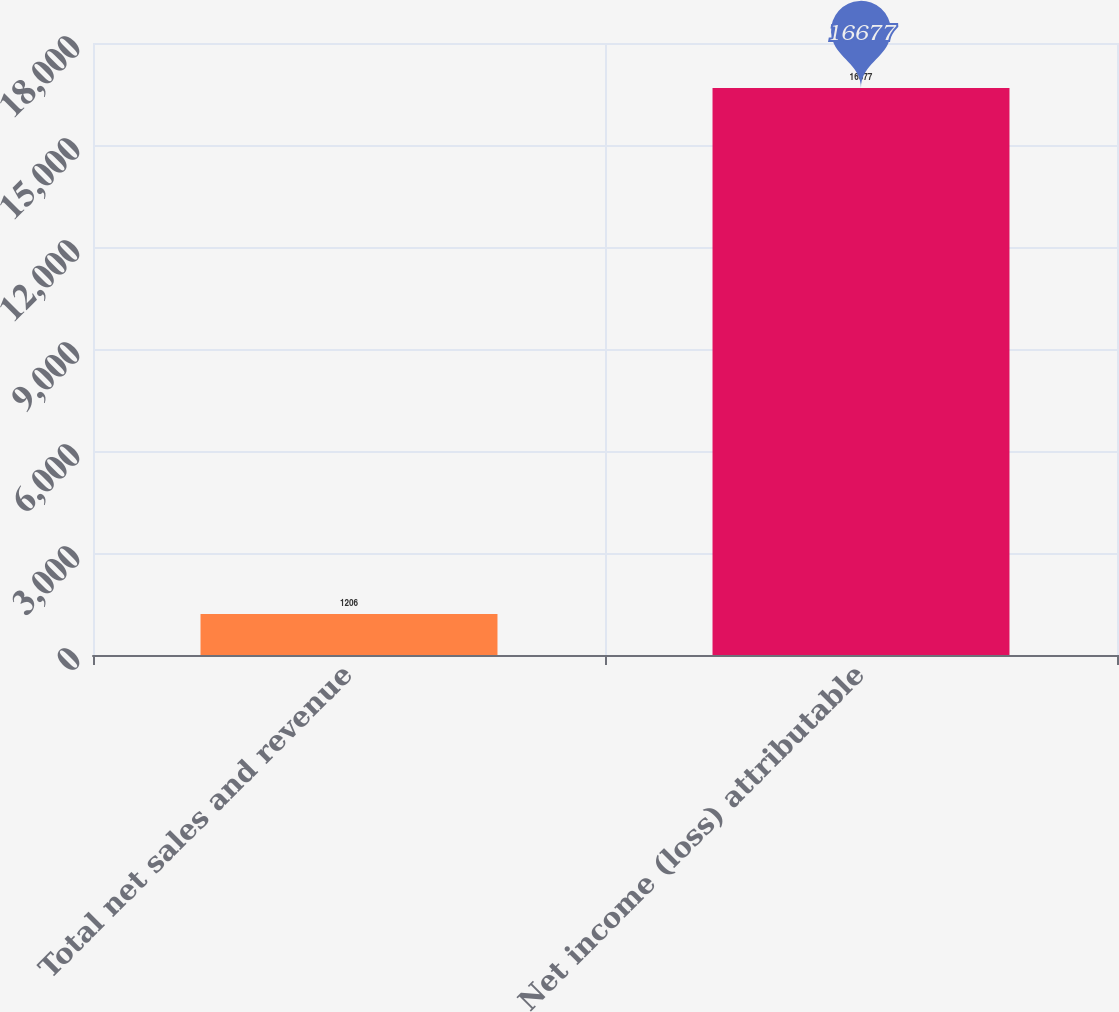<chart> <loc_0><loc_0><loc_500><loc_500><bar_chart><fcel>Total net sales and revenue<fcel>Net income (loss) attributable<nl><fcel>1206<fcel>16677<nl></chart> 